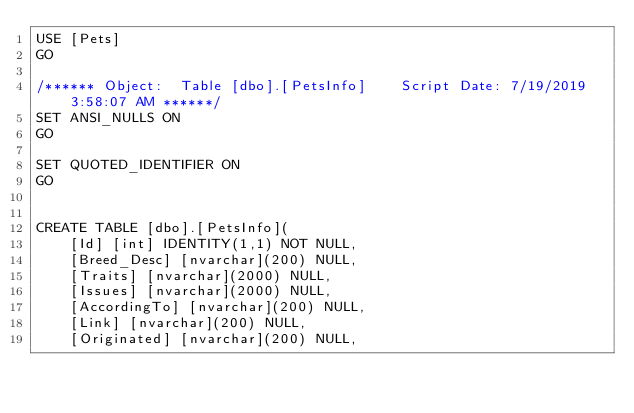<code> <loc_0><loc_0><loc_500><loc_500><_SQL_>USE [Pets]
GO

/****** Object:  Table [dbo].[PetsInfo]    Script Date: 7/19/2019 3:58:07 AM ******/
SET ANSI_NULLS ON
GO

SET QUOTED_IDENTIFIER ON
GO


CREATE TABLE [dbo].[PetsInfo](
	[Id] [int] IDENTITY(1,1) NOT NULL,
	[Breed_Desc] [nvarchar](200) NULL,
	[Traits] [nvarchar](2000) NULL,
	[Issues] [nvarchar](2000) NULL,
	[AccordingTo] [nvarchar](200) NULL,
	[Link] [nvarchar](200) NULL,
	[Originated] [nvarchar](200) NULL,</code> 